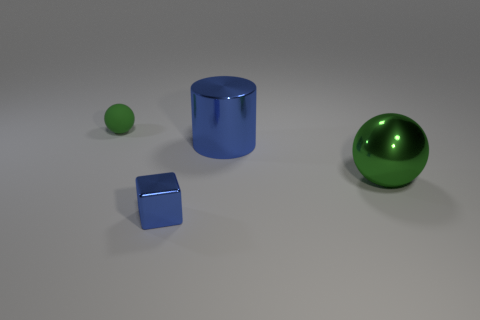Add 2 small shiny blocks. How many objects exist? 6 Subtract all cylinders. How many objects are left? 3 Add 1 brown things. How many brown things exist? 1 Subtract 1 blue cubes. How many objects are left? 3 Subtract all gray metallic balls. Subtract all large blue cylinders. How many objects are left? 3 Add 2 large metallic things. How many large metallic things are left? 4 